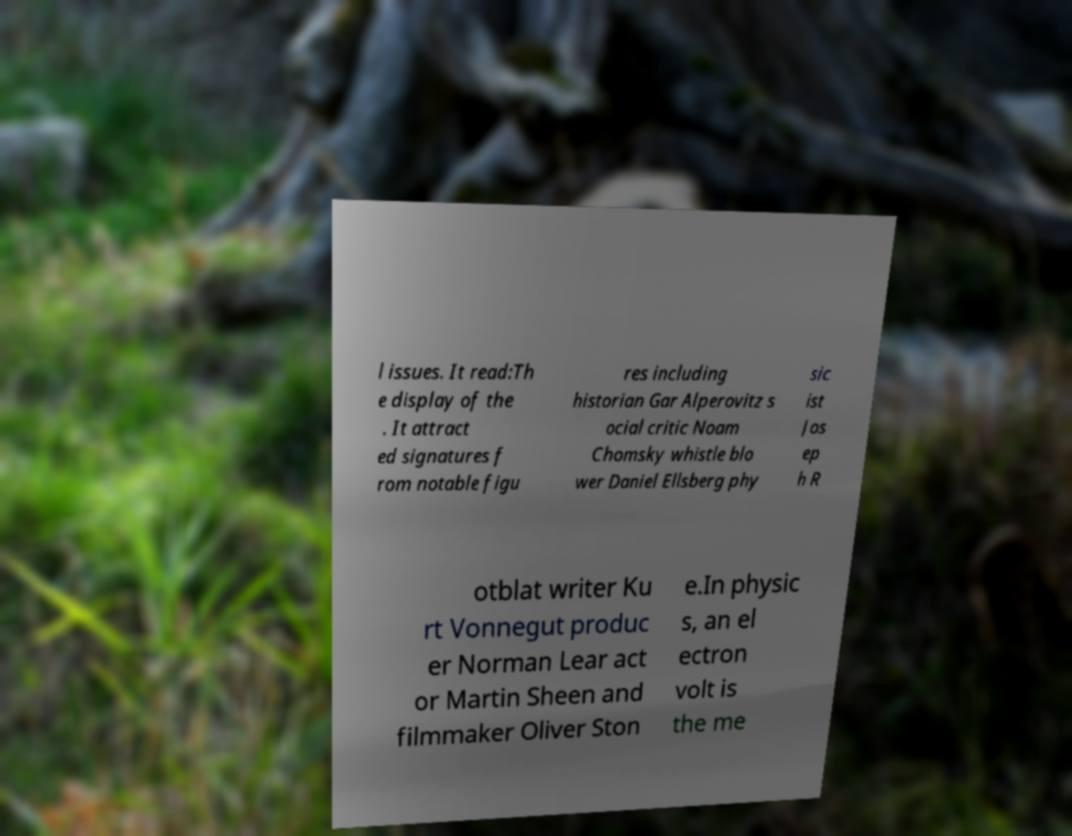Can you accurately transcribe the text from the provided image for me? l issues. It read:Th e display of the . It attract ed signatures f rom notable figu res including historian Gar Alperovitz s ocial critic Noam Chomsky whistle blo wer Daniel Ellsberg phy sic ist Jos ep h R otblat writer Ku rt Vonnegut produc er Norman Lear act or Martin Sheen and filmmaker Oliver Ston e.In physic s, an el ectron volt is the me 